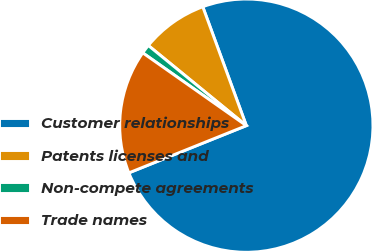<chart> <loc_0><loc_0><loc_500><loc_500><pie_chart><fcel>Customer relationships<fcel>Patents licenses and<fcel>Non-compete agreements<fcel>Trade names<nl><fcel>74.51%<fcel>8.5%<fcel>1.16%<fcel>15.83%<nl></chart> 